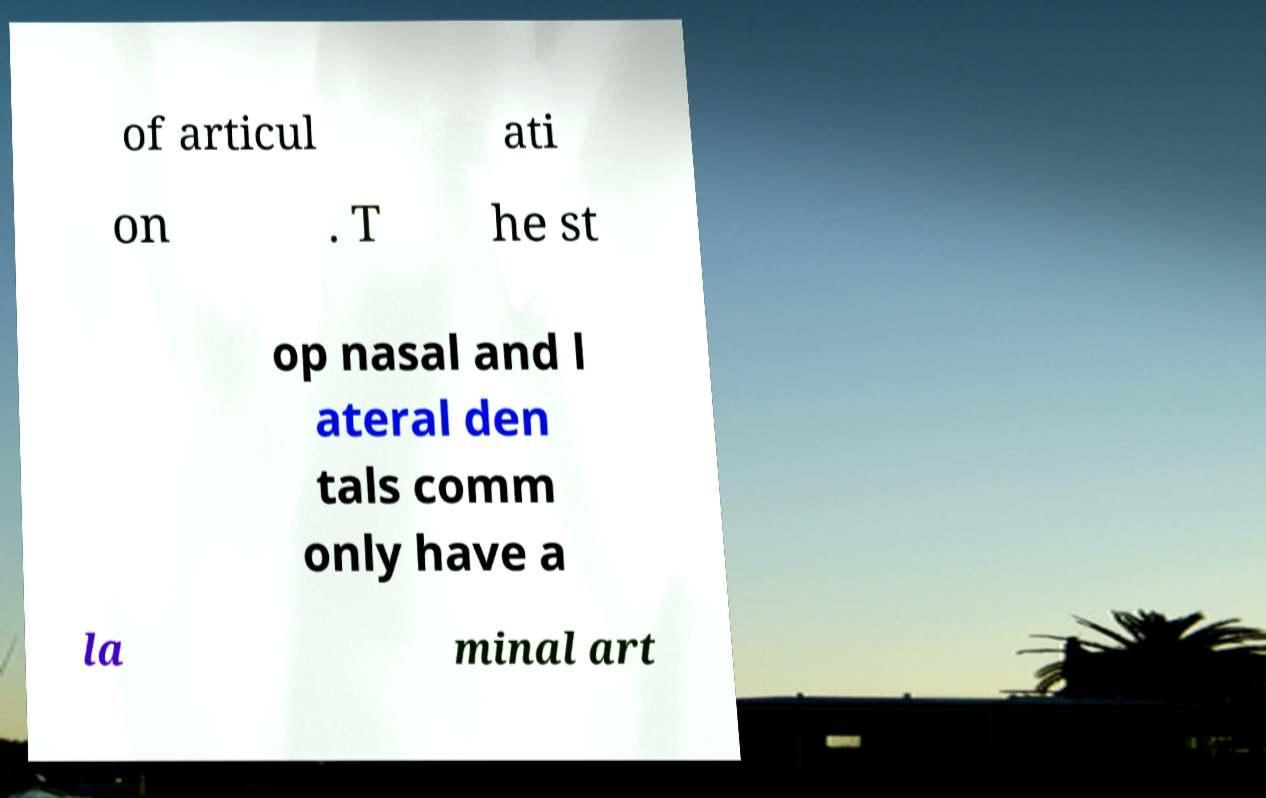Can you read and provide the text displayed in the image?This photo seems to have some interesting text. Can you extract and type it out for me? of articul ati on . T he st op nasal and l ateral den tals comm only have a la minal art 